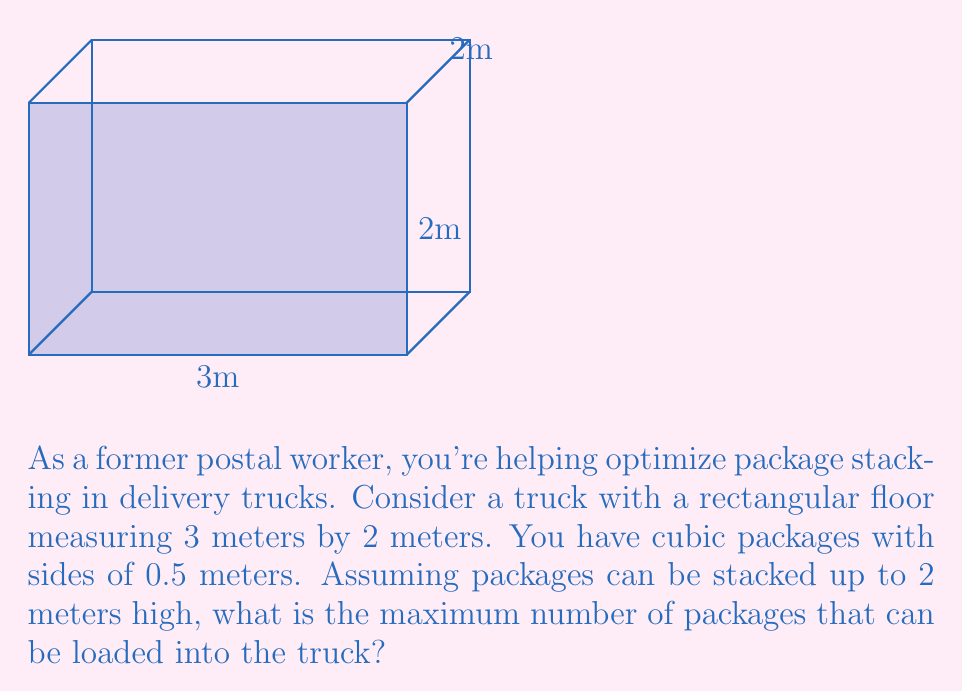Provide a solution to this math problem. Let's approach this step-by-step:

1) First, let's calculate the number of packages that can fit on the floor:
   - Length of the floor: $3 \text{ m} \div 0.5 \text{ m} = 6$ packages
   - Width of the floor: $2 \text{ m} \div 0.5 \text{ m} = 4$ packages
   - Total on floor: $6 \times 4 = 24$ packages

2) Now, let's determine how many layers we can stack:
   - Height limit: $2 \text{ m}$
   - Package height: $0.5 \text{ m}$
   - Number of layers: $2 \text{ m} \div 0.5 \text{ m} = 4$ layers

3) To find the total number of packages, we multiply the number on the floor by the number of layers:
   $$ \text{Total packages} = 24 \times 4 = 96 $$

Therefore, the maximum number of packages that can be loaded into the truck is 96.
Answer: 96 packages 